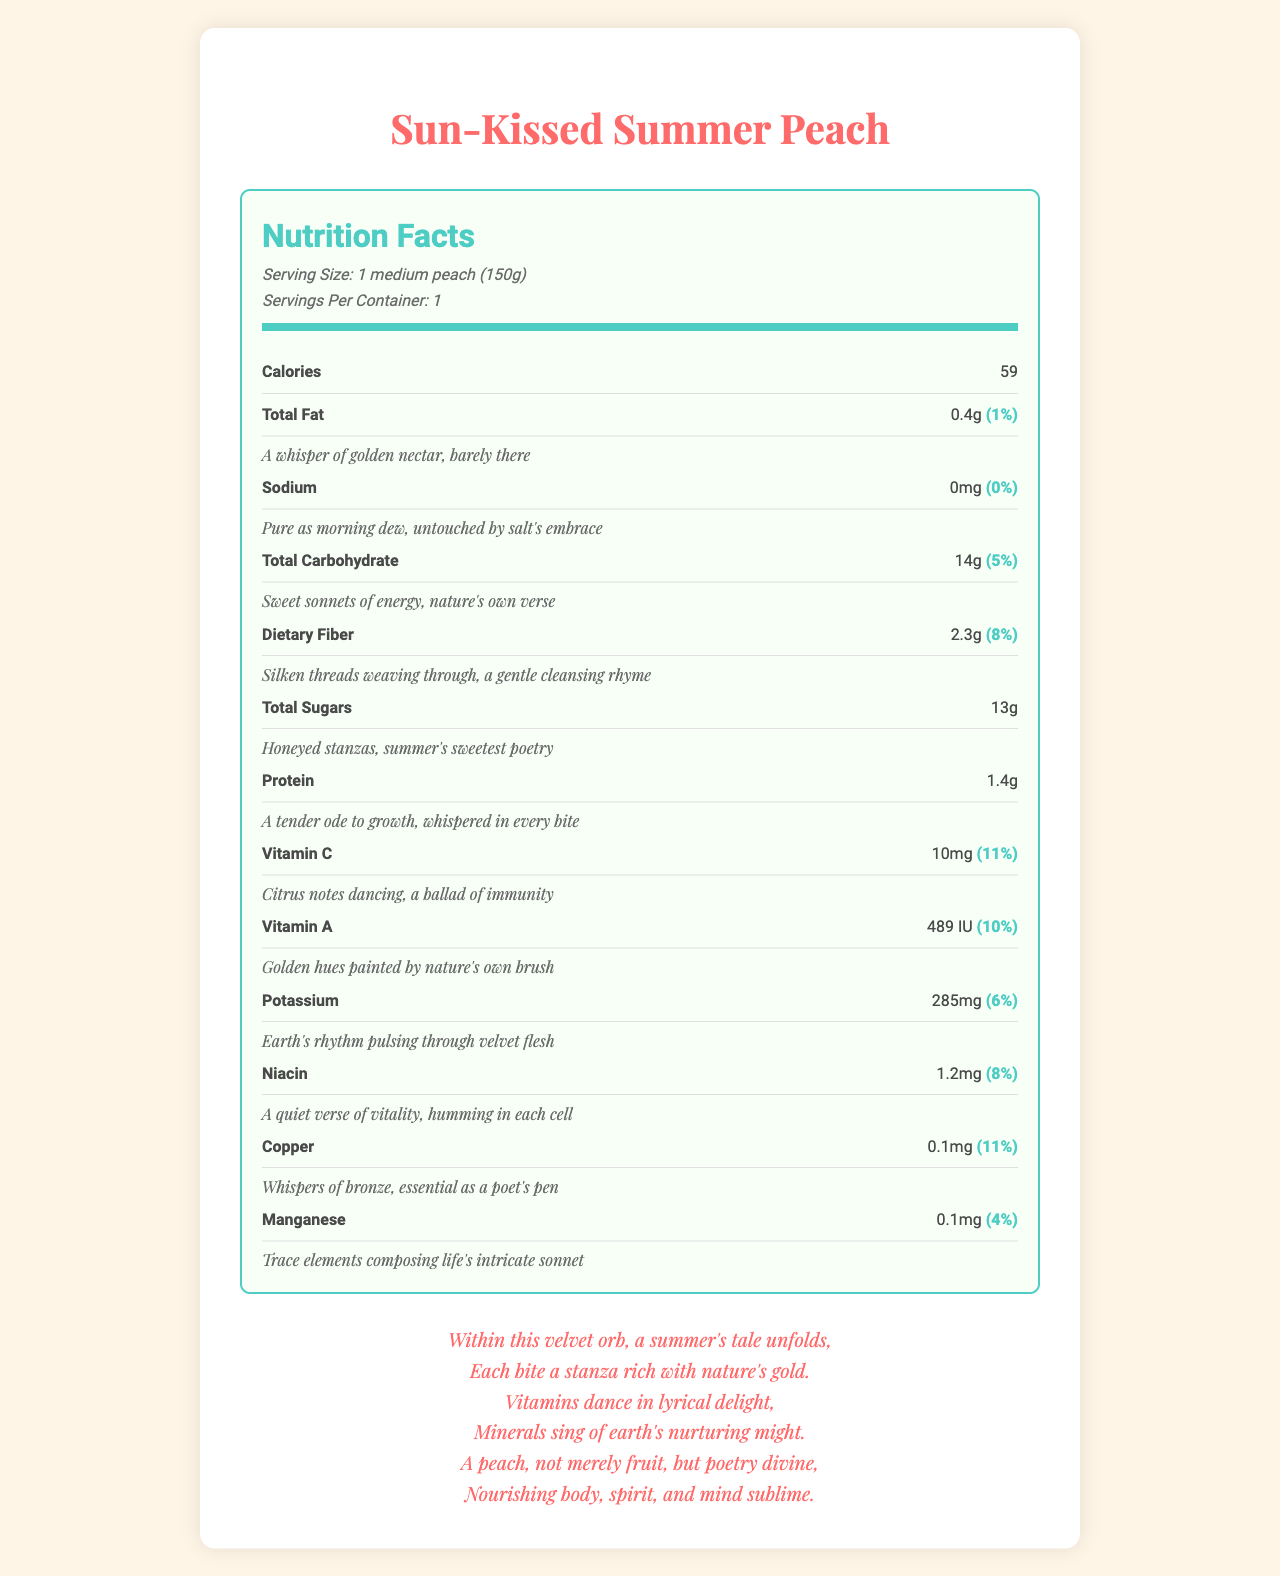what is the serving size of the Sun-Kissed Summer Peach? The serving size is clearly stated at the top of the nutrition label: "Serving Size: 1 medium peach (150g)".
Answer: 1 medium peach (150g) how many calories are in one serving? The document states under Calories: "59".
Answer: 59 what percentage of the daily value of Vitamin C does one serving provide? Under Vitamin C, it’s mentioned: "10mg (11%)".
Answer: 11% what is the poetic description of the total sugars content? The description for Total Sugars reads: "Honeyed stanzas, summer's sweetest poetry".
Answer: Honeyed stanzas, summer's sweetest poetry how much potassium is in one serving? The document specifies under Potassium: "285mg (6%)".
Answer: 285mg what is the product name? The product name is stated at the very top of the document: "Product Name: Sun-Kissed Summer Peach".
Answer: Sun-Kissed Summer Peach how many grams of protein are found in a serving? A. 0.4g B. 1.4g C. 2.3g D. 285mg The document mentions under Protein: "1.4g".
Answer: B which of the following descriptions matches the content of dietary fiber? A. A whisper of golden nectar, barely there B. Nature's own verses, guarding against time's relentless march C. Silken threads weaving through, a gentle cleansing rhyme D. Trace elements composing life's intricate sonnet The description for Dietary Fiber reads: "Silken threads weaving through, a gentle cleansing rhyme".
Answer: C is there any sodium in the Sun-Kissed Summer Peach? The document states under Sodium: "0mg (0%)", with the description: "Pure as morning dew, untouched by salt's embrace".
Answer: No summarize the main theme of the document. The document lists different nutritional elements such as Calories, Total Fat, Sodium, Carbohydrate, Fiber, Sugars, and Protein in the Sun-Kissed Summer Peach, with lyrical descriptions highlighting the essence and beauty of each nutrient. It also includes final poetic lines summarizing the peach as a nourishing and sublime experience.
Answer: The document presents the nutritional facts of the Sun-Kissed Summer Peach, beautifully describing the amounts and benefits of various vitamins and minerals it contains, with an overarching poetic narrative. how are antioxidants described in the document? In the section listing additional nutrients, Antioxidants are described as: "Nature's own verses, guarding against time's relentless march".
Answer: Nature's own verses, guarding against time's relentless march who wrote the lyrical descriptions? The document does not provide any information regarding the author of the lyrical descriptions; hence, this cannot be determined from the visual content of the document.
Answer: Cannot be determined 